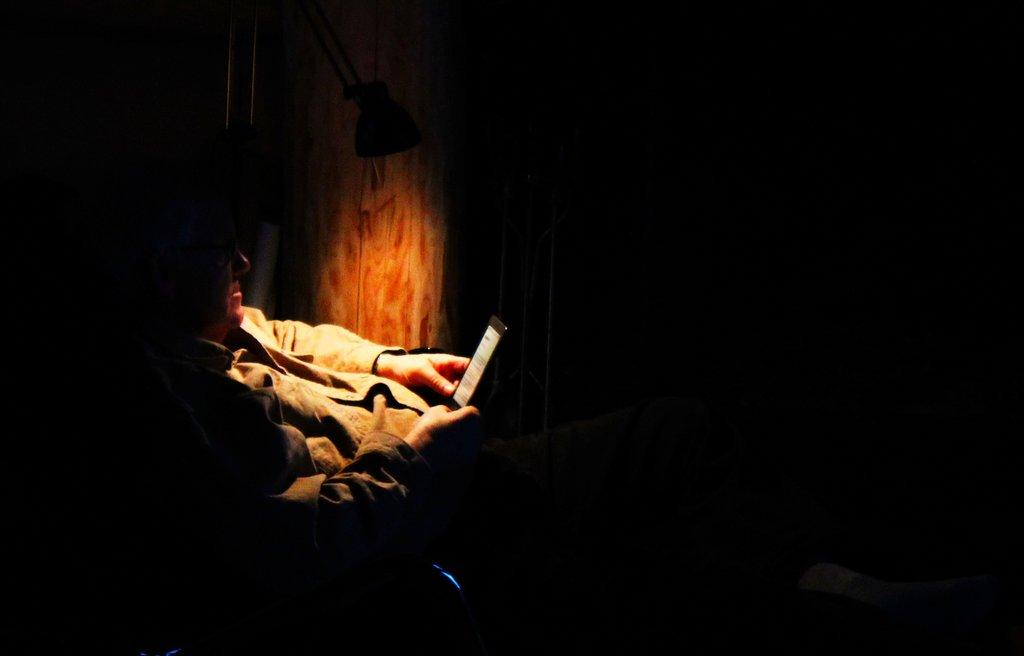What can be observed about the lighting in the image? The corners of the image are dark. Can you describe the main subject in the image? There is a person in the image. What is the person wearing? The person is wearing clothes. What is the person holding in their hand? The person is holding a device in their hand. What object can be seen providing light in the image? There is a lamp visible in the image. Is there a tree visible in the image during the rainstorm? There is no rainstorm or tree present in the image. 